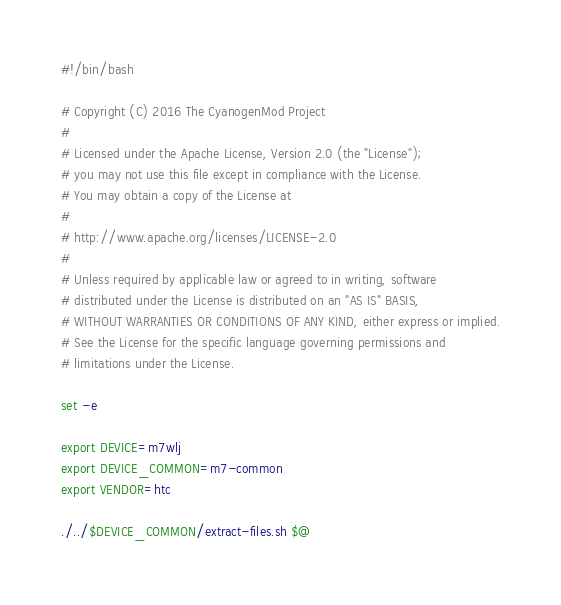Convert code to text. <code><loc_0><loc_0><loc_500><loc_500><_Bash_>#!/bin/bash

# Copyright (C) 2016 The CyanogenMod Project
#
# Licensed under the Apache License, Version 2.0 (the "License");
# you may not use this file except in compliance with the License.
# You may obtain a copy of the License at
#
# http://www.apache.org/licenses/LICENSE-2.0
#
# Unless required by applicable law or agreed to in writing, software
# distributed under the License is distributed on an "AS IS" BASIS,
# WITHOUT WARRANTIES OR CONDITIONS OF ANY KIND, either express or implied.
# See the License for the specific language governing permissions and
# limitations under the License.

set -e

export DEVICE=m7wlj
export DEVICE_COMMON=m7-common
export VENDOR=htc

./../$DEVICE_COMMON/extract-files.sh $@
</code> 